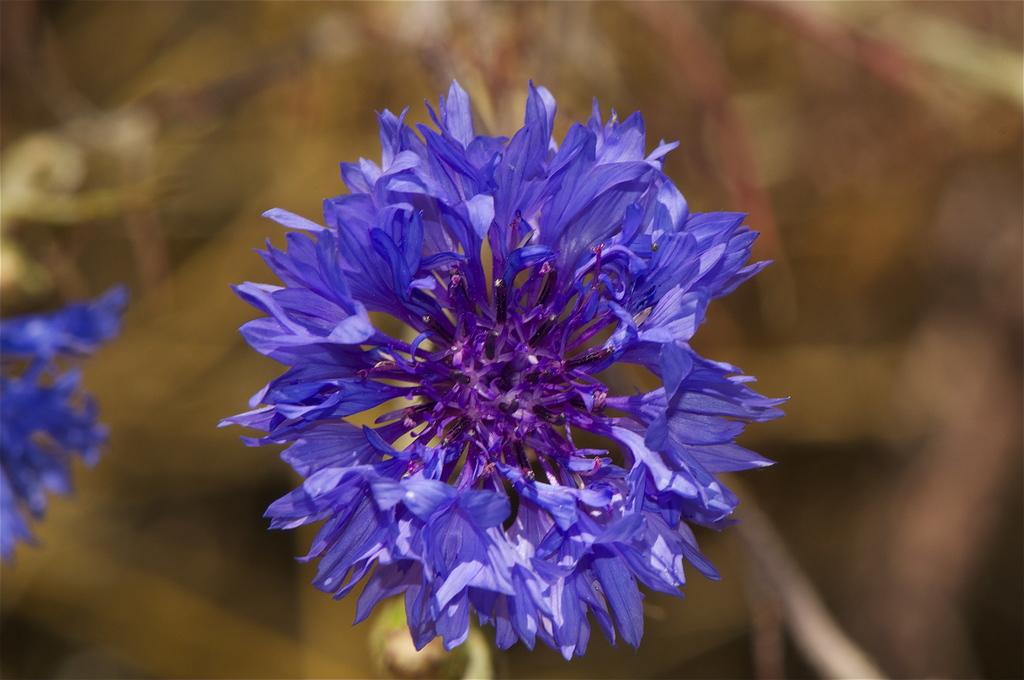What type of flower is in the image? There is a beautiful purple flower in the image. What color is the background of the flower? The background of the flower is blue. What time does the clock show in the image? There is no clock present in the image. 